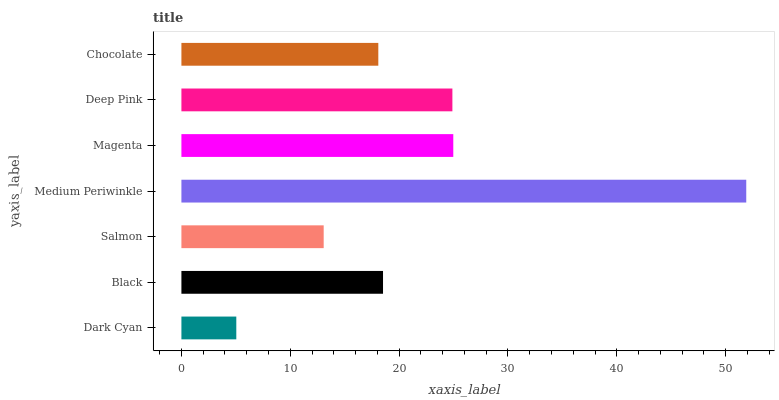Is Dark Cyan the minimum?
Answer yes or no. Yes. Is Medium Periwinkle the maximum?
Answer yes or no. Yes. Is Black the minimum?
Answer yes or no. No. Is Black the maximum?
Answer yes or no. No. Is Black greater than Dark Cyan?
Answer yes or no. Yes. Is Dark Cyan less than Black?
Answer yes or no. Yes. Is Dark Cyan greater than Black?
Answer yes or no. No. Is Black less than Dark Cyan?
Answer yes or no. No. Is Black the high median?
Answer yes or no. Yes. Is Black the low median?
Answer yes or no. Yes. Is Magenta the high median?
Answer yes or no. No. Is Magenta the low median?
Answer yes or no. No. 